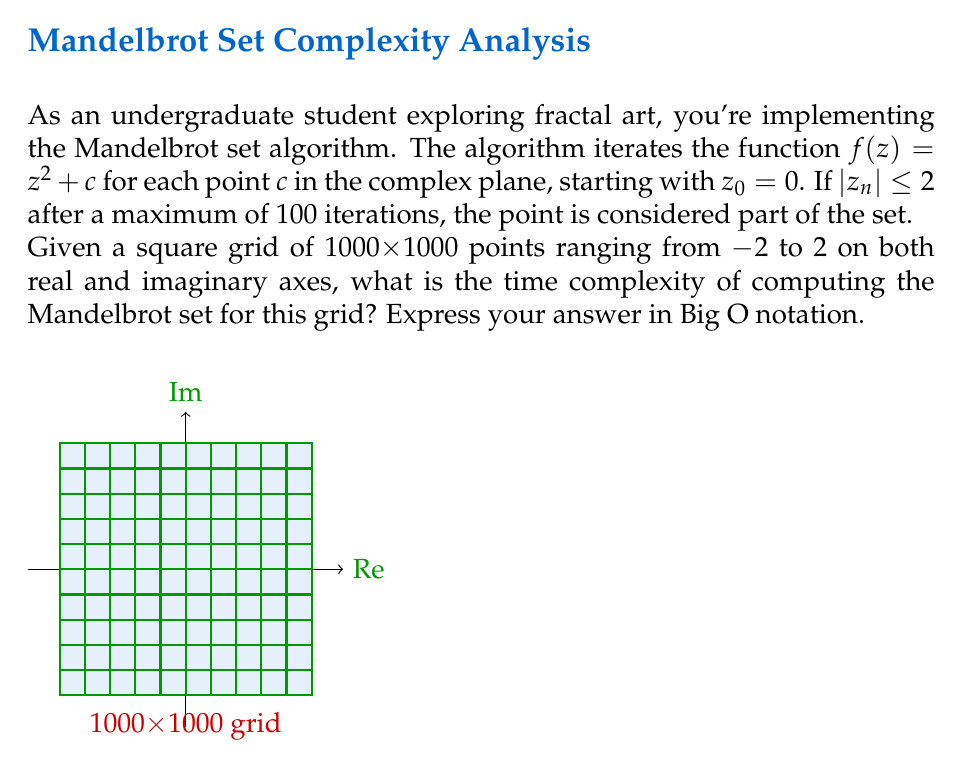Can you answer this question? Let's break down the problem and analyze the computational complexity step by step:

1) We have a 1000x1000 grid, so the total number of points to check is $1000 * 1000 = 10^6$.

2) For each point, we perform the Mandelbrot set iteration:
   $$z_{n+1} = z_n^2 + c$$

3) We iterate this function up to 100 times for each point, or until $|z_n| > 2$.

4) Each iteration involves:
   - One complex multiplication ($z_n^2$)
   - One complex addition ($+ c$)
   - One magnitude calculation ($|z_{n+1}|$)
   - One comparison ($|z_{n+1}| \leq 2$)

5) These operations are considered constant time operations for complex numbers.

6) In the worst case, we perform all 100 iterations for each point.

7) Therefore, for each point, we have O(100) = O(1) operations (since 100 is a constant).

8) We perform these operations for all $10^6$ points in the grid.

Thus, the overall time complexity is:

$$O(10^6 * 1) = O(10^6) = O(N)$$

where N is the total number of points in the grid.

Note: While the grid size is fixed at 1000x1000 in this problem, if we consider N as a variable representing the total number of points (N = grid_size^2), the complexity would still be O(N).
Answer: O(N) 